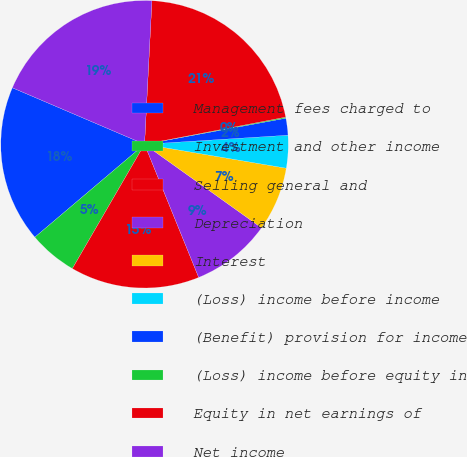Convert chart to OTSL. <chart><loc_0><loc_0><loc_500><loc_500><pie_chart><fcel>Management fees charged to<fcel>Investment and other income<fcel>Selling general and<fcel>Depreciation<fcel>Interest<fcel>(Loss) income before income<fcel>(Benefit) provision for income<fcel>(Loss) income before equity in<fcel>Equity in net earnings of<fcel>Net income<nl><fcel>17.62%<fcel>5.44%<fcel>14.52%<fcel>8.98%<fcel>7.21%<fcel>3.67%<fcel>1.9%<fcel>0.12%<fcel>21.16%<fcel>19.39%<nl></chart> 